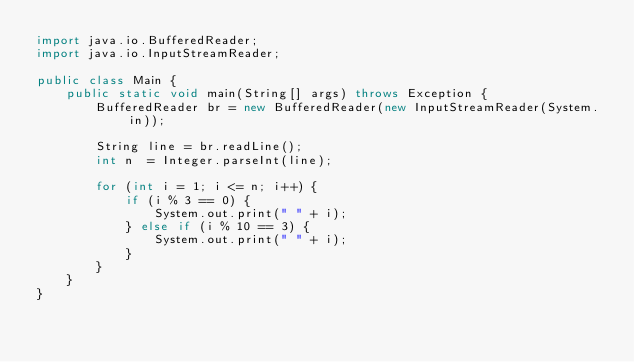<code> <loc_0><loc_0><loc_500><loc_500><_Java_>import java.io.BufferedReader;
import java.io.InputStreamReader;

public class Main {
	public static void main(String[] args) throws Exception {
		BufferedReader br = new BufferedReader(new InputStreamReader(System.in));

		String line = br.readLine();
		int n  = Integer.parseInt(line);

		for (int i = 1; i <= n; i++) {
			if (i % 3 == 0) {
				System.out.print(" " + i);
			} else if (i % 10 == 3) {
				System.out.print(" " + i);
			}
		}
	}
}</code> 